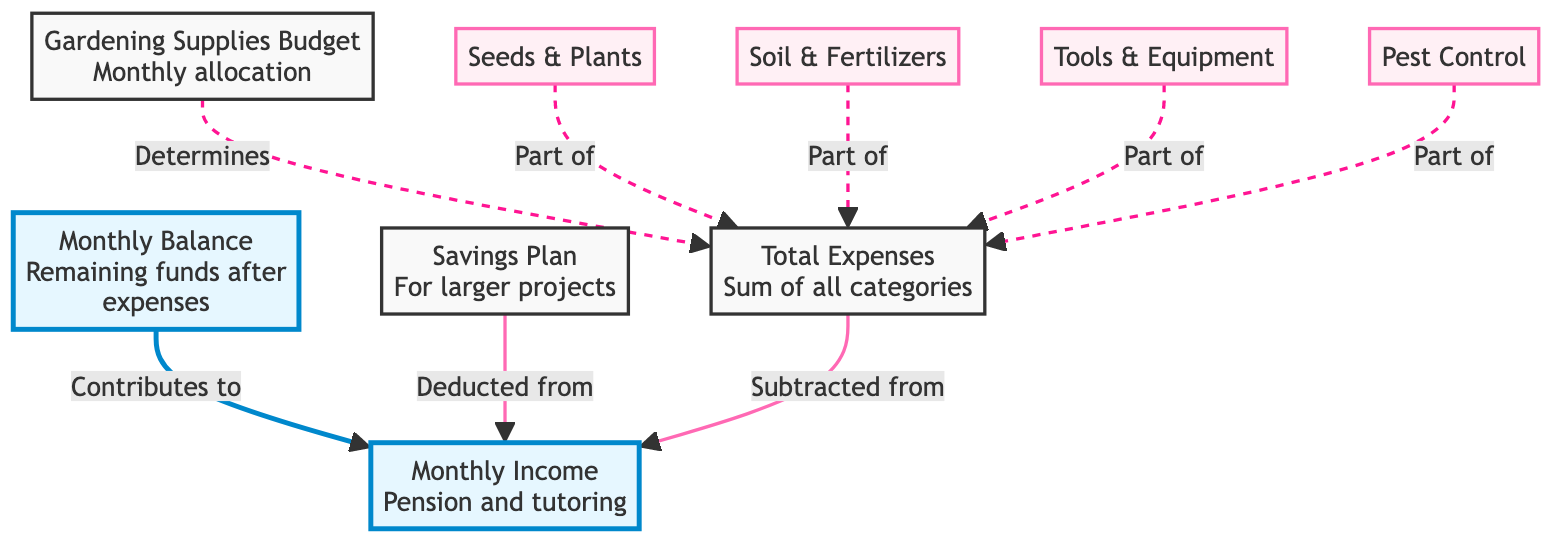What is the main source of income represented in the diagram? The diagram identifies "Monthly Income" as the source of funds. The description notes this is from pension and part-time tutoring.
Answer: Monthly Income What contributes to the Monthly Balance? The "Monthly Balance" is derived from subtracting "Total Expenses" and "Savings Plan" from "Monthly Income." The diagram indicates a sequential relationship leading into the balance.
Answer: Total Expenses and Savings Plan How many expense categories are outlined in the chart? By examining the "Expense Categories" node, there are four specific subcategories: "Seeds & Plants," "Soil & Fertilizers," "Tools & Equipment," and "Pest Control." This count includes all listed categories.
Answer: Four What determines the Total Expenses in the gardening budget? The "Total Expenses" are determined by summing the costs from all expense categories listed under "Expense Categories," which are part of the overall gardening supplies budget.
Answer: Gardening Supplies Budget If the Monthly Income is decreased, what will happen to the Monthly Balance? If "Monthly Income" is decreased, it directly affects the "Monthly Balance" by lowering its value since the balance is calculated as income minus expenses and savings. Thus, a decrease in income results in a lower balance.
Answer: Decrease Which expense category is associated with new seeds and plants? The expense category specifically related to new seeds and plants is named "Seeds & Plants," as noted in the breakdown of categories within the diagram.
Answer: Seeds & Plants Is the Savings Plan included in the Total Expenses calculation? No, the "Savings Plan" is not included in the "Total Expenses," as it is deducted from the "Monthly Income" before finalizing monthly balance calculations.
Answer: No What visual element indicates high importance in the diagram? The nodes labeled "Monthly Balance" and "Monthly Income" are highlighted with a blue fill, indicating their high importance in the flow of flowchart, representing vital components in the budget analysis.
Answer: Blue fill How does the Monthly Income affect the budgeting process? "Monthly Income" serves as the primary starting point for the budgeting process, influencing allocations to various categories, expenses, and the final balance, as these all derive from it.
Answer: Primary starting point 